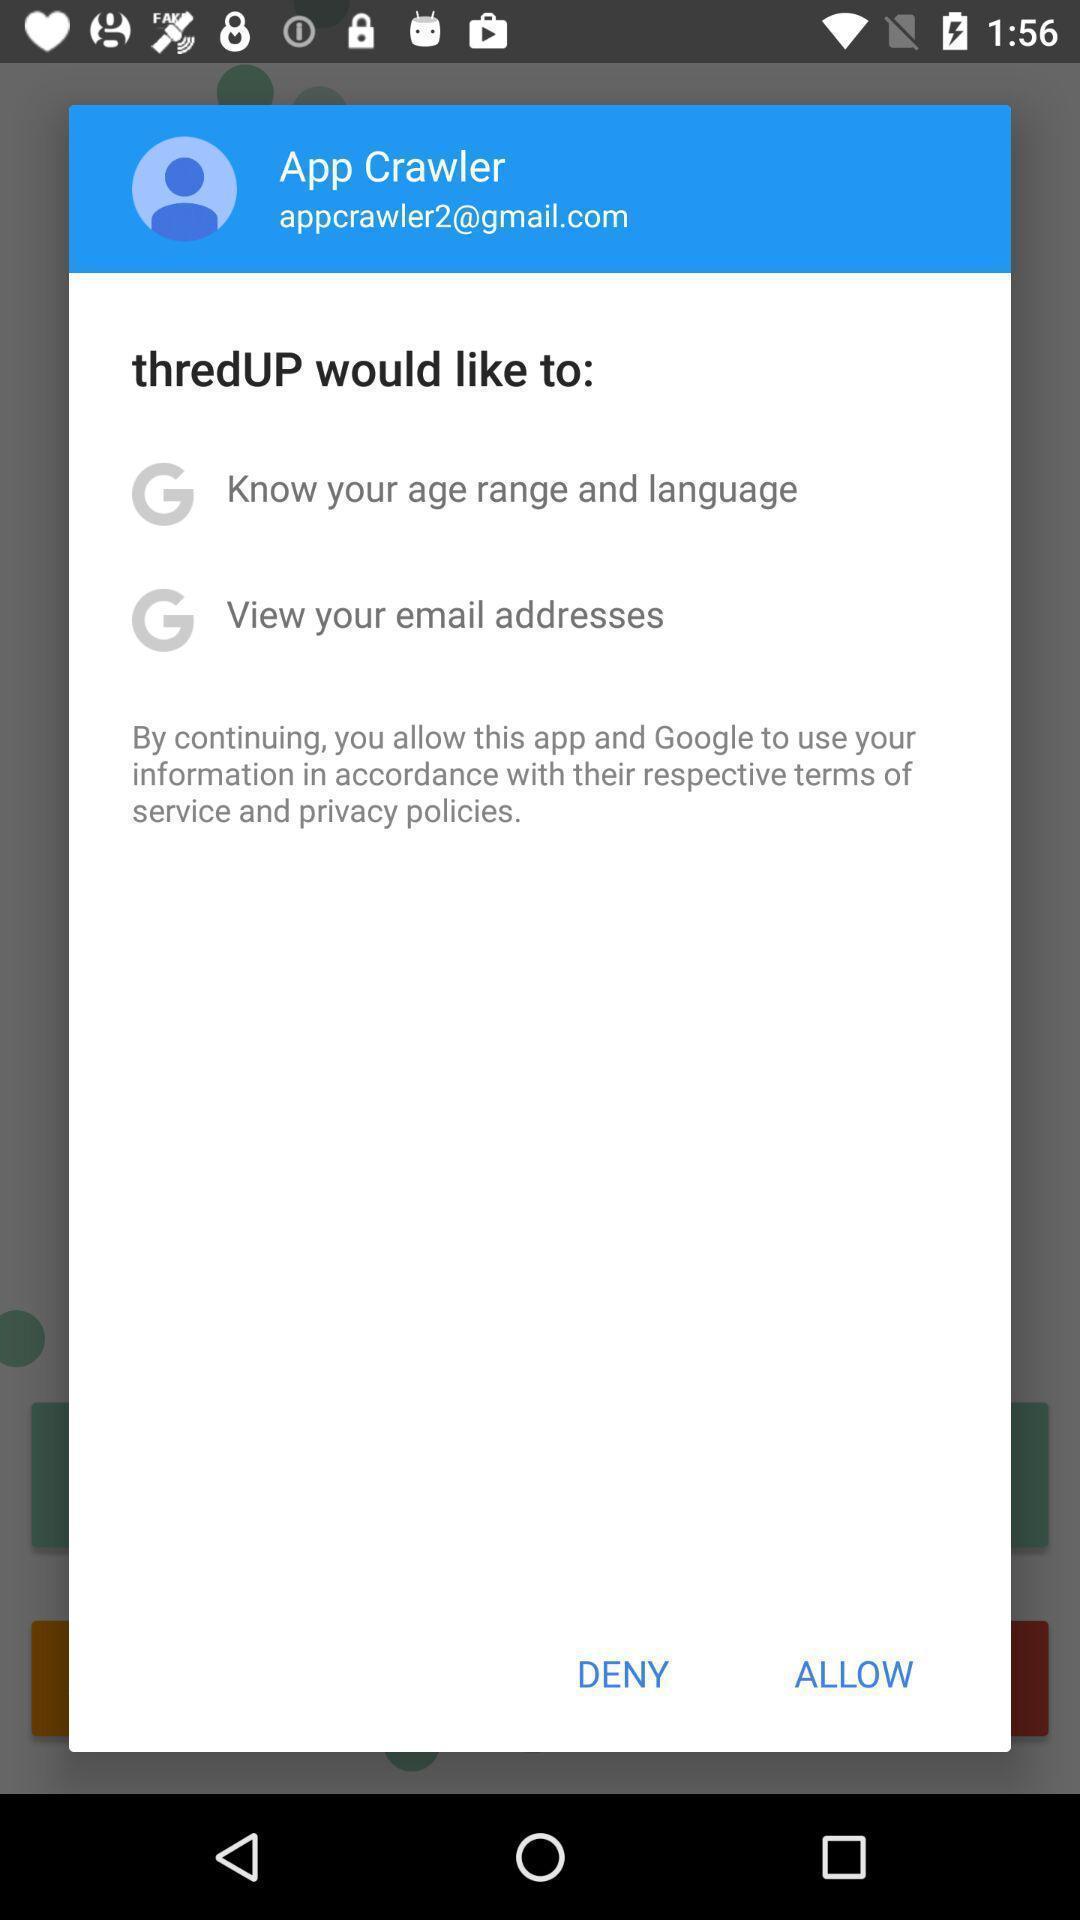Explain the elements present in this screenshot. Various options in a clothing app. 